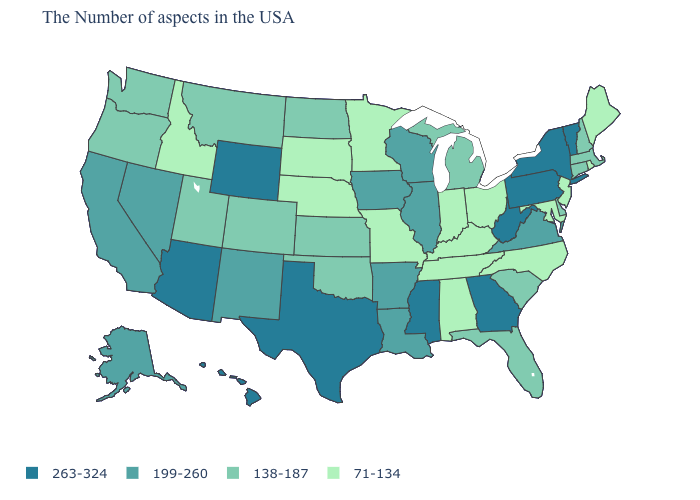Which states have the highest value in the USA?
Concise answer only. Vermont, New York, Pennsylvania, West Virginia, Georgia, Mississippi, Texas, Wyoming, Arizona, Hawaii. What is the highest value in states that border Ohio?
Concise answer only. 263-324. What is the value of Arkansas?
Concise answer only. 199-260. What is the value of Vermont?
Be succinct. 263-324. Name the states that have a value in the range 71-134?
Short answer required. Maine, Rhode Island, New Jersey, Maryland, North Carolina, Ohio, Kentucky, Indiana, Alabama, Tennessee, Missouri, Minnesota, Nebraska, South Dakota, Idaho. What is the highest value in the USA?
Quick response, please. 263-324. Name the states that have a value in the range 71-134?
Quick response, please. Maine, Rhode Island, New Jersey, Maryland, North Carolina, Ohio, Kentucky, Indiana, Alabama, Tennessee, Missouri, Minnesota, Nebraska, South Dakota, Idaho. What is the lowest value in the MidWest?
Give a very brief answer. 71-134. Among the states that border Ohio , does Pennsylvania have the highest value?
Answer briefly. Yes. Is the legend a continuous bar?
Write a very short answer. No. What is the lowest value in the USA?
Write a very short answer. 71-134. What is the value of Alaska?
Concise answer only. 199-260. Does Pennsylvania have the lowest value in the Northeast?
Keep it brief. No. Is the legend a continuous bar?
Be succinct. No. Does the map have missing data?
Answer briefly. No. 